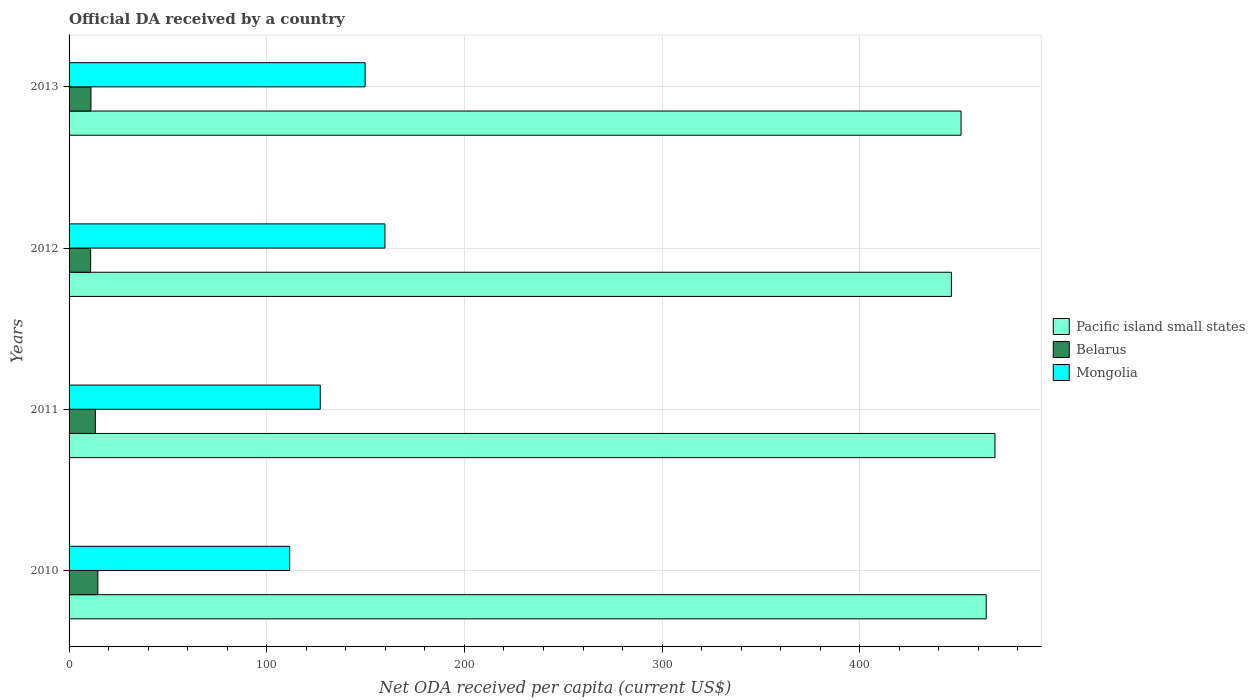How many different coloured bars are there?
Your response must be concise. 3. Are the number of bars on each tick of the Y-axis equal?
Give a very brief answer. Yes. How many bars are there on the 3rd tick from the top?
Your response must be concise. 3. How many bars are there on the 2nd tick from the bottom?
Provide a short and direct response. 3. What is the label of the 1st group of bars from the top?
Offer a terse response. 2013. In how many cases, is the number of bars for a given year not equal to the number of legend labels?
Ensure brevity in your answer.  0. What is the ODA received in in Belarus in 2010?
Ensure brevity in your answer.  14.55. Across all years, what is the maximum ODA received in in Pacific island small states?
Keep it short and to the point. 468.42. Across all years, what is the minimum ODA received in in Pacific island small states?
Give a very brief answer. 446.37. In which year was the ODA received in in Mongolia maximum?
Your answer should be compact. 2012. What is the total ODA received in in Mongolia in the graph?
Your response must be concise. 548.27. What is the difference between the ODA received in in Belarus in 2010 and that in 2011?
Provide a succinct answer. 1.25. What is the difference between the ODA received in in Pacific island small states in 2011 and the ODA received in in Mongolia in 2012?
Make the answer very short. 308.62. What is the average ODA received in in Belarus per year?
Your answer should be very brief. 12.46. In the year 2012, what is the difference between the ODA received in in Belarus and ODA received in in Pacific island small states?
Provide a succinct answer. -435.46. What is the ratio of the ODA received in in Mongolia in 2011 to that in 2013?
Your answer should be compact. 0.85. Is the difference between the ODA received in in Belarus in 2012 and 2013 greater than the difference between the ODA received in in Pacific island small states in 2012 and 2013?
Provide a succinct answer. Yes. What is the difference between the highest and the second highest ODA received in in Pacific island small states?
Your response must be concise. 4.43. What is the difference between the highest and the lowest ODA received in in Pacific island small states?
Ensure brevity in your answer.  22.05. Is the sum of the ODA received in in Mongolia in 2010 and 2013 greater than the maximum ODA received in in Pacific island small states across all years?
Ensure brevity in your answer.  No. What does the 2nd bar from the top in 2010 represents?
Provide a short and direct response. Belarus. What does the 2nd bar from the bottom in 2012 represents?
Your answer should be compact. Belarus. How many bars are there?
Keep it short and to the point. 12. Are all the bars in the graph horizontal?
Make the answer very short. Yes. How many years are there in the graph?
Offer a very short reply. 4. Does the graph contain grids?
Give a very brief answer. Yes. How many legend labels are there?
Offer a very short reply. 3. What is the title of the graph?
Provide a short and direct response. Official DA received by a country. Does "Lesotho" appear as one of the legend labels in the graph?
Provide a short and direct response. No. What is the label or title of the X-axis?
Offer a terse response. Net ODA received per capita (current US$). What is the Net ODA received per capita (current US$) in Pacific island small states in 2010?
Offer a very short reply. 463.99. What is the Net ODA received per capita (current US$) in Belarus in 2010?
Ensure brevity in your answer.  14.55. What is the Net ODA received per capita (current US$) in Mongolia in 2010?
Offer a very short reply. 111.61. What is the Net ODA received per capita (current US$) of Pacific island small states in 2011?
Ensure brevity in your answer.  468.42. What is the Net ODA received per capita (current US$) in Belarus in 2011?
Offer a terse response. 13.3. What is the Net ODA received per capita (current US$) of Mongolia in 2011?
Offer a terse response. 127.07. What is the Net ODA received per capita (current US$) of Pacific island small states in 2012?
Ensure brevity in your answer.  446.37. What is the Net ODA received per capita (current US$) of Belarus in 2012?
Keep it short and to the point. 10.91. What is the Net ODA received per capita (current US$) in Mongolia in 2012?
Keep it short and to the point. 159.8. What is the Net ODA received per capita (current US$) in Pacific island small states in 2013?
Your response must be concise. 451.26. What is the Net ODA received per capita (current US$) in Belarus in 2013?
Provide a succinct answer. 11.06. What is the Net ODA received per capita (current US$) in Mongolia in 2013?
Give a very brief answer. 149.79. Across all years, what is the maximum Net ODA received per capita (current US$) of Pacific island small states?
Provide a short and direct response. 468.42. Across all years, what is the maximum Net ODA received per capita (current US$) in Belarus?
Ensure brevity in your answer.  14.55. Across all years, what is the maximum Net ODA received per capita (current US$) of Mongolia?
Give a very brief answer. 159.8. Across all years, what is the minimum Net ODA received per capita (current US$) in Pacific island small states?
Your response must be concise. 446.37. Across all years, what is the minimum Net ODA received per capita (current US$) in Belarus?
Provide a succinct answer. 10.91. Across all years, what is the minimum Net ODA received per capita (current US$) of Mongolia?
Your response must be concise. 111.61. What is the total Net ODA received per capita (current US$) of Pacific island small states in the graph?
Ensure brevity in your answer.  1830.05. What is the total Net ODA received per capita (current US$) of Belarus in the graph?
Provide a succinct answer. 49.82. What is the total Net ODA received per capita (current US$) of Mongolia in the graph?
Offer a terse response. 548.27. What is the difference between the Net ODA received per capita (current US$) of Pacific island small states in 2010 and that in 2011?
Make the answer very short. -4.43. What is the difference between the Net ODA received per capita (current US$) in Belarus in 2010 and that in 2011?
Offer a very short reply. 1.25. What is the difference between the Net ODA received per capita (current US$) of Mongolia in 2010 and that in 2011?
Give a very brief answer. -15.46. What is the difference between the Net ODA received per capita (current US$) of Pacific island small states in 2010 and that in 2012?
Your answer should be compact. 17.62. What is the difference between the Net ODA received per capita (current US$) of Belarus in 2010 and that in 2012?
Offer a terse response. 3.64. What is the difference between the Net ODA received per capita (current US$) of Mongolia in 2010 and that in 2012?
Give a very brief answer. -48.19. What is the difference between the Net ODA received per capita (current US$) in Pacific island small states in 2010 and that in 2013?
Your response must be concise. 12.73. What is the difference between the Net ODA received per capita (current US$) of Belarus in 2010 and that in 2013?
Provide a short and direct response. 3.49. What is the difference between the Net ODA received per capita (current US$) in Mongolia in 2010 and that in 2013?
Your response must be concise. -38.18. What is the difference between the Net ODA received per capita (current US$) in Pacific island small states in 2011 and that in 2012?
Ensure brevity in your answer.  22.05. What is the difference between the Net ODA received per capita (current US$) of Belarus in 2011 and that in 2012?
Your answer should be very brief. 2.39. What is the difference between the Net ODA received per capita (current US$) in Mongolia in 2011 and that in 2012?
Ensure brevity in your answer.  -32.73. What is the difference between the Net ODA received per capita (current US$) in Pacific island small states in 2011 and that in 2013?
Your answer should be very brief. 17.16. What is the difference between the Net ODA received per capita (current US$) of Belarus in 2011 and that in 2013?
Make the answer very short. 2.24. What is the difference between the Net ODA received per capita (current US$) in Mongolia in 2011 and that in 2013?
Provide a succinct answer. -22.72. What is the difference between the Net ODA received per capita (current US$) in Pacific island small states in 2012 and that in 2013?
Keep it short and to the point. -4.89. What is the difference between the Net ODA received per capita (current US$) of Belarus in 2012 and that in 2013?
Offer a very short reply. -0.15. What is the difference between the Net ODA received per capita (current US$) in Mongolia in 2012 and that in 2013?
Provide a short and direct response. 10.01. What is the difference between the Net ODA received per capita (current US$) of Pacific island small states in 2010 and the Net ODA received per capita (current US$) of Belarus in 2011?
Keep it short and to the point. 450.69. What is the difference between the Net ODA received per capita (current US$) of Pacific island small states in 2010 and the Net ODA received per capita (current US$) of Mongolia in 2011?
Offer a very short reply. 336.92. What is the difference between the Net ODA received per capita (current US$) in Belarus in 2010 and the Net ODA received per capita (current US$) in Mongolia in 2011?
Your response must be concise. -112.52. What is the difference between the Net ODA received per capita (current US$) in Pacific island small states in 2010 and the Net ODA received per capita (current US$) in Belarus in 2012?
Your answer should be compact. 453.08. What is the difference between the Net ODA received per capita (current US$) in Pacific island small states in 2010 and the Net ODA received per capita (current US$) in Mongolia in 2012?
Your answer should be very brief. 304.19. What is the difference between the Net ODA received per capita (current US$) of Belarus in 2010 and the Net ODA received per capita (current US$) of Mongolia in 2012?
Offer a very short reply. -145.25. What is the difference between the Net ODA received per capita (current US$) of Pacific island small states in 2010 and the Net ODA received per capita (current US$) of Belarus in 2013?
Your answer should be compact. 452.93. What is the difference between the Net ODA received per capita (current US$) of Pacific island small states in 2010 and the Net ODA received per capita (current US$) of Mongolia in 2013?
Provide a succinct answer. 314.2. What is the difference between the Net ODA received per capita (current US$) in Belarus in 2010 and the Net ODA received per capita (current US$) in Mongolia in 2013?
Your response must be concise. -135.23. What is the difference between the Net ODA received per capita (current US$) of Pacific island small states in 2011 and the Net ODA received per capita (current US$) of Belarus in 2012?
Your answer should be very brief. 457.51. What is the difference between the Net ODA received per capita (current US$) of Pacific island small states in 2011 and the Net ODA received per capita (current US$) of Mongolia in 2012?
Your response must be concise. 308.62. What is the difference between the Net ODA received per capita (current US$) in Belarus in 2011 and the Net ODA received per capita (current US$) in Mongolia in 2012?
Provide a short and direct response. -146.5. What is the difference between the Net ODA received per capita (current US$) of Pacific island small states in 2011 and the Net ODA received per capita (current US$) of Belarus in 2013?
Provide a succinct answer. 457.36. What is the difference between the Net ODA received per capita (current US$) of Pacific island small states in 2011 and the Net ODA received per capita (current US$) of Mongolia in 2013?
Keep it short and to the point. 318.63. What is the difference between the Net ODA received per capita (current US$) in Belarus in 2011 and the Net ODA received per capita (current US$) in Mongolia in 2013?
Provide a short and direct response. -136.49. What is the difference between the Net ODA received per capita (current US$) in Pacific island small states in 2012 and the Net ODA received per capita (current US$) in Belarus in 2013?
Ensure brevity in your answer.  435.32. What is the difference between the Net ODA received per capita (current US$) of Pacific island small states in 2012 and the Net ODA received per capita (current US$) of Mongolia in 2013?
Offer a terse response. 296.59. What is the difference between the Net ODA received per capita (current US$) in Belarus in 2012 and the Net ODA received per capita (current US$) in Mongolia in 2013?
Your answer should be compact. -138.88. What is the average Net ODA received per capita (current US$) in Pacific island small states per year?
Your response must be concise. 457.51. What is the average Net ODA received per capita (current US$) in Belarus per year?
Give a very brief answer. 12.46. What is the average Net ODA received per capita (current US$) of Mongolia per year?
Provide a short and direct response. 137.07. In the year 2010, what is the difference between the Net ODA received per capita (current US$) in Pacific island small states and Net ODA received per capita (current US$) in Belarus?
Provide a short and direct response. 449.44. In the year 2010, what is the difference between the Net ODA received per capita (current US$) of Pacific island small states and Net ODA received per capita (current US$) of Mongolia?
Offer a very short reply. 352.38. In the year 2010, what is the difference between the Net ODA received per capita (current US$) in Belarus and Net ODA received per capita (current US$) in Mongolia?
Give a very brief answer. -97.06. In the year 2011, what is the difference between the Net ODA received per capita (current US$) of Pacific island small states and Net ODA received per capita (current US$) of Belarus?
Your response must be concise. 455.12. In the year 2011, what is the difference between the Net ODA received per capita (current US$) in Pacific island small states and Net ODA received per capita (current US$) in Mongolia?
Your answer should be compact. 341.35. In the year 2011, what is the difference between the Net ODA received per capita (current US$) in Belarus and Net ODA received per capita (current US$) in Mongolia?
Offer a terse response. -113.77. In the year 2012, what is the difference between the Net ODA received per capita (current US$) of Pacific island small states and Net ODA received per capita (current US$) of Belarus?
Your answer should be compact. 435.46. In the year 2012, what is the difference between the Net ODA received per capita (current US$) of Pacific island small states and Net ODA received per capita (current US$) of Mongolia?
Ensure brevity in your answer.  286.57. In the year 2012, what is the difference between the Net ODA received per capita (current US$) of Belarus and Net ODA received per capita (current US$) of Mongolia?
Provide a succinct answer. -148.89. In the year 2013, what is the difference between the Net ODA received per capita (current US$) of Pacific island small states and Net ODA received per capita (current US$) of Belarus?
Provide a short and direct response. 440.2. In the year 2013, what is the difference between the Net ODA received per capita (current US$) in Pacific island small states and Net ODA received per capita (current US$) in Mongolia?
Give a very brief answer. 301.47. In the year 2013, what is the difference between the Net ODA received per capita (current US$) of Belarus and Net ODA received per capita (current US$) of Mongolia?
Provide a succinct answer. -138.73. What is the ratio of the Net ODA received per capita (current US$) of Pacific island small states in 2010 to that in 2011?
Keep it short and to the point. 0.99. What is the ratio of the Net ODA received per capita (current US$) of Belarus in 2010 to that in 2011?
Ensure brevity in your answer.  1.09. What is the ratio of the Net ODA received per capita (current US$) in Mongolia in 2010 to that in 2011?
Keep it short and to the point. 0.88. What is the ratio of the Net ODA received per capita (current US$) in Pacific island small states in 2010 to that in 2012?
Provide a short and direct response. 1.04. What is the ratio of the Net ODA received per capita (current US$) in Belarus in 2010 to that in 2012?
Provide a short and direct response. 1.33. What is the ratio of the Net ODA received per capita (current US$) in Mongolia in 2010 to that in 2012?
Ensure brevity in your answer.  0.7. What is the ratio of the Net ODA received per capita (current US$) in Pacific island small states in 2010 to that in 2013?
Offer a very short reply. 1.03. What is the ratio of the Net ODA received per capita (current US$) of Belarus in 2010 to that in 2013?
Provide a succinct answer. 1.32. What is the ratio of the Net ODA received per capita (current US$) in Mongolia in 2010 to that in 2013?
Keep it short and to the point. 0.75. What is the ratio of the Net ODA received per capita (current US$) in Pacific island small states in 2011 to that in 2012?
Ensure brevity in your answer.  1.05. What is the ratio of the Net ODA received per capita (current US$) of Belarus in 2011 to that in 2012?
Your answer should be very brief. 1.22. What is the ratio of the Net ODA received per capita (current US$) in Mongolia in 2011 to that in 2012?
Your answer should be compact. 0.8. What is the ratio of the Net ODA received per capita (current US$) in Pacific island small states in 2011 to that in 2013?
Offer a very short reply. 1.04. What is the ratio of the Net ODA received per capita (current US$) in Belarus in 2011 to that in 2013?
Your response must be concise. 1.2. What is the ratio of the Net ODA received per capita (current US$) in Mongolia in 2011 to that in 2013?
Offer a very short reply. 0.85. What is the ratio of the Net ODA received per capita (current US$) of Belarus in 2012 to that in 2013?
Your answer should be compact. 0.99. What is the ratio of the Net ODA received per capita (current US$) in Mongolia in 2012 to that in 2013?
Offer a terse response. 1.07. What is the difference between the highest and the second highest Net ODA received per capita (current US$) of Pacific island small states?
Your response must be concise. 4.43. What is the difference between the highest and the second highest Net ODA received per capita (current US$) of Belarus?
Make the answer very short. 1.25. What is the difference between the highest and the second highest Net ODA received per capita (current US$) of Mongolia?
Your answer should be very brief. 10.01. What is the difference between the highest and the lowest Net ODA received per capita (current US$) of Pacific island small states?
Provide a short and direct response. 22.05. What is the difference between the highest and the lowest Net ODA received per capita (current US$) in Belarus?
Keep it short and to the point. 3.64. What is the difference between the highest and the lowest Net ODA received per capita (current US$) of Mongolia?
Keep it short and to the point. 48.19. 